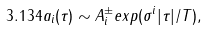Convert formula to latex. <formula><loc_0><loc_0><loc_500><loc_500>3 . 1 3 4 a _ { i } ( \tau ) \sim A _ { i } ^ { \pm } e x p ( \sigma ^ { i } | \tau | / T ) ,</formula> 